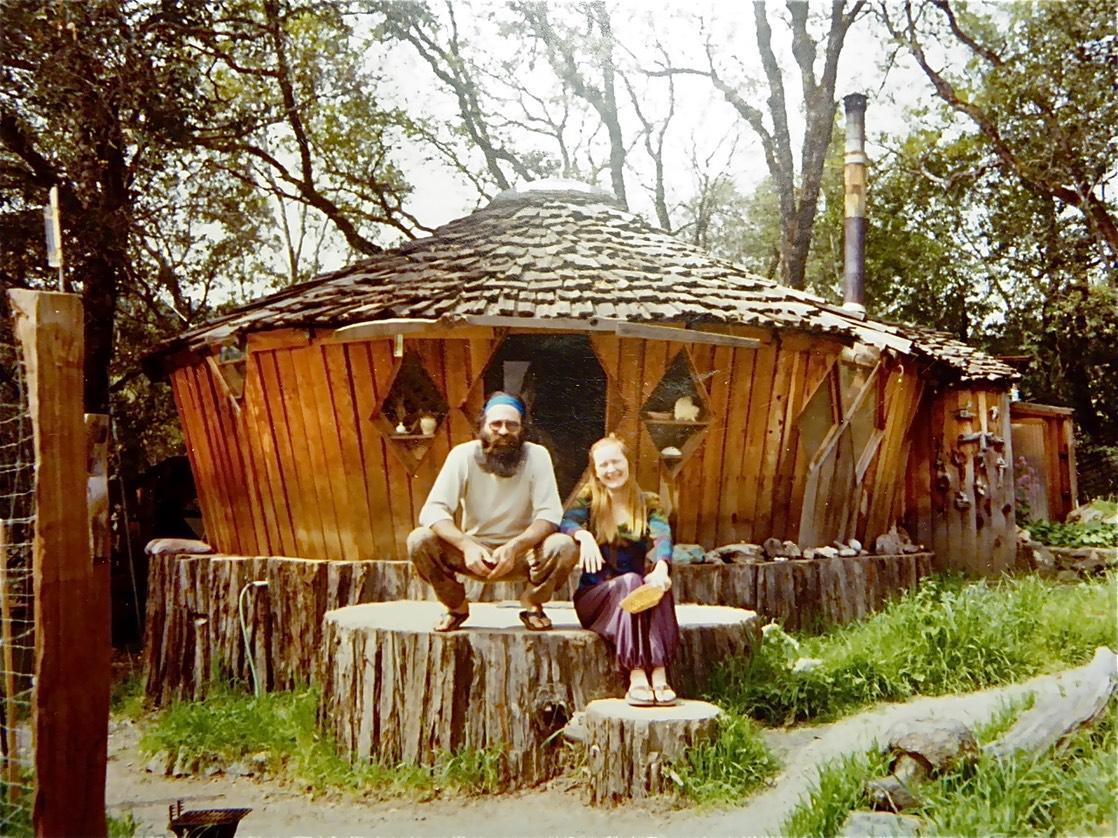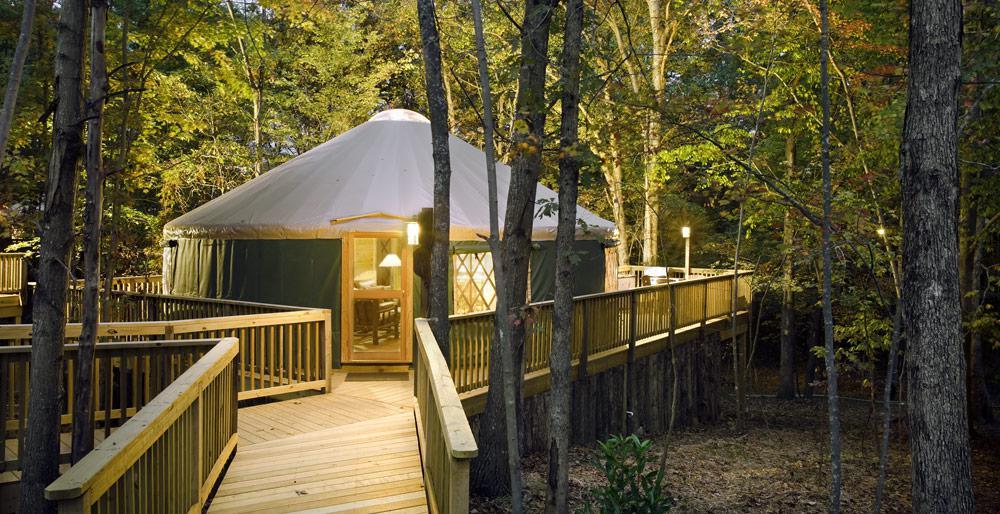The first image is the image on the left, the second image is the image on the right. For the images shown, is this caption "There is an ax in the image on the right." true? Answer yes or no. No. 